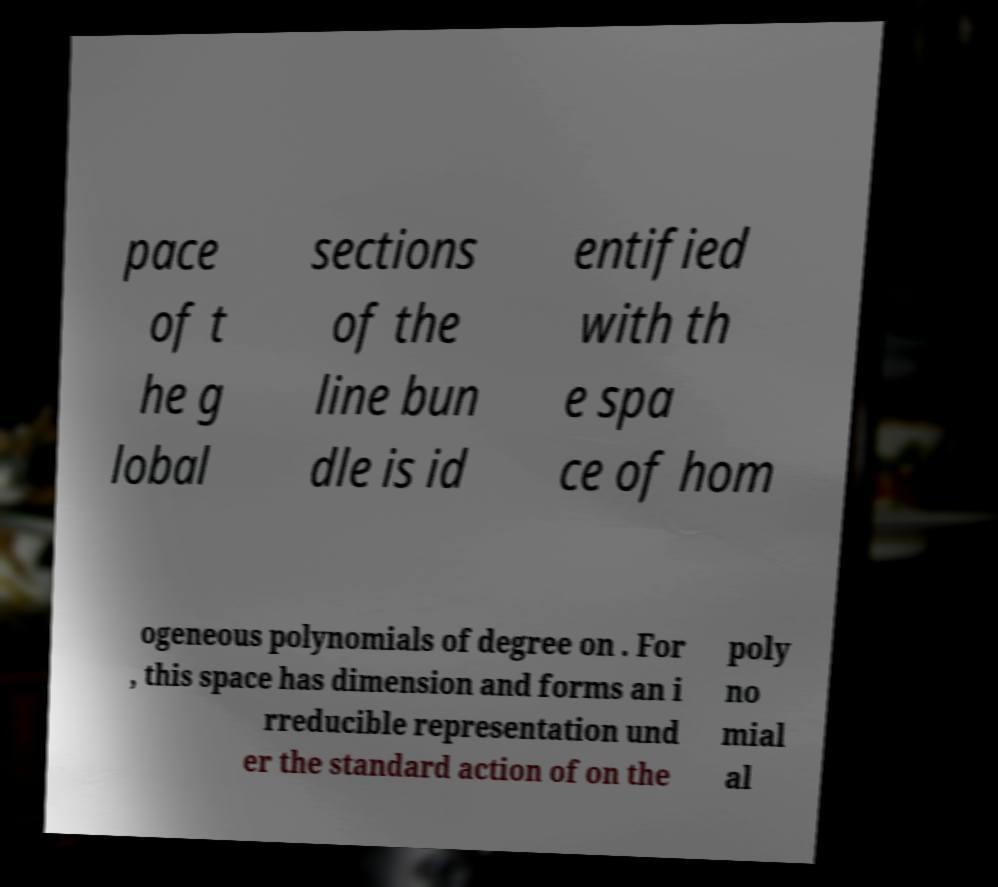Please read and relay the text visible in this image. What does it say? pace of t he g lobal sections of the line bun dle is id entified with th e spa ce of hom ogeneous polynomials of degree on . For , this space has dimension and forms an i rreducible representation und er the standard action of on the poly no mial al 